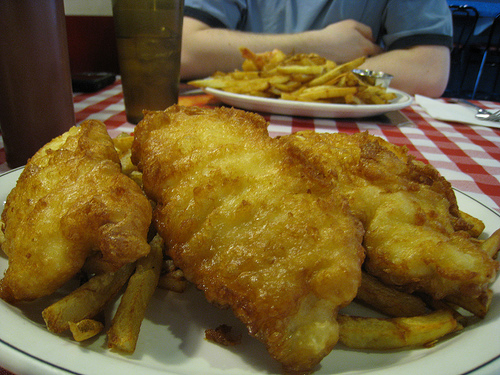<image>
Is there a fish filet under the tablecloth? No. The fish filet is not positioned under the tablecloth. The vertical relationship between these objects is different. 